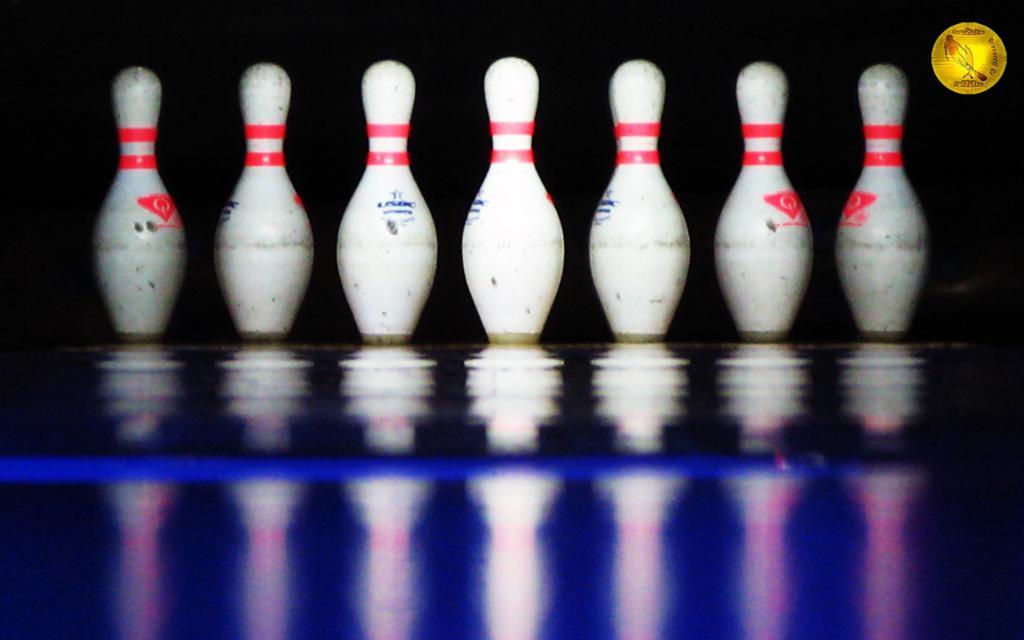Please provide a concise description of this image. Here we can see bowling pins on the floor. On this floor we can see the reflection of bowling pins. 